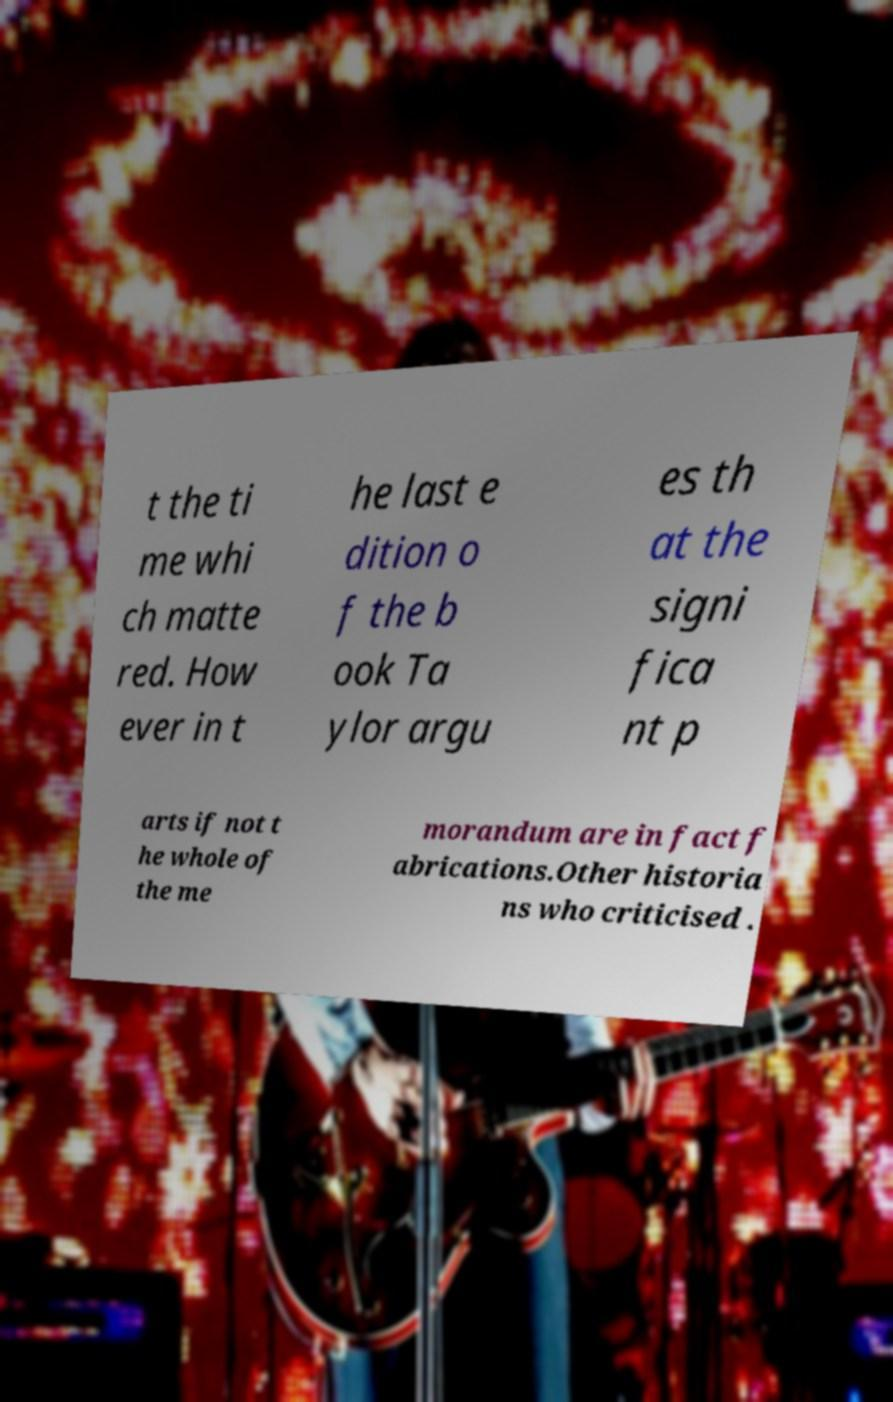Could you extract and type out the text from this image? t the ti me whi ch matte red. How ever in t he last e dition o f the b ook Ta ylor argu es th at the signi fica nt p arts if not t he whole of the me morandum are in fact f abrications.Other historia ns who criticised . 